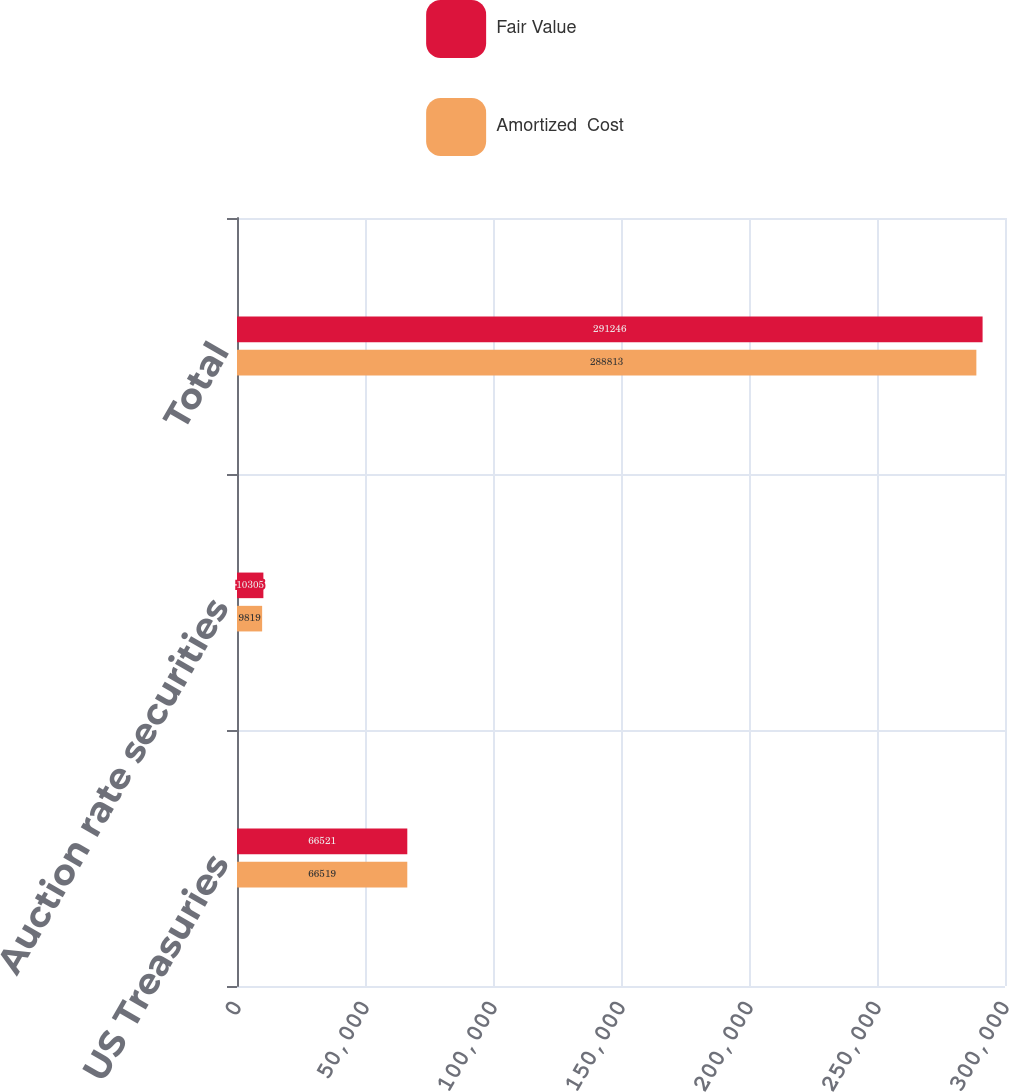<chart> <loc_0><loc_0><loc_500><loc_500><stacked_bar_chart><ecel><fcel>US Treasuries<fcel>Auction rate securities<fcel>Total<nl><fcel>Fair Value<fcel>66521<fcel>10305<fcel>291246<nl><fcel>Amortized  Cost<fcel>66519<fcel>9819<fcel>288813<nl></chart> 